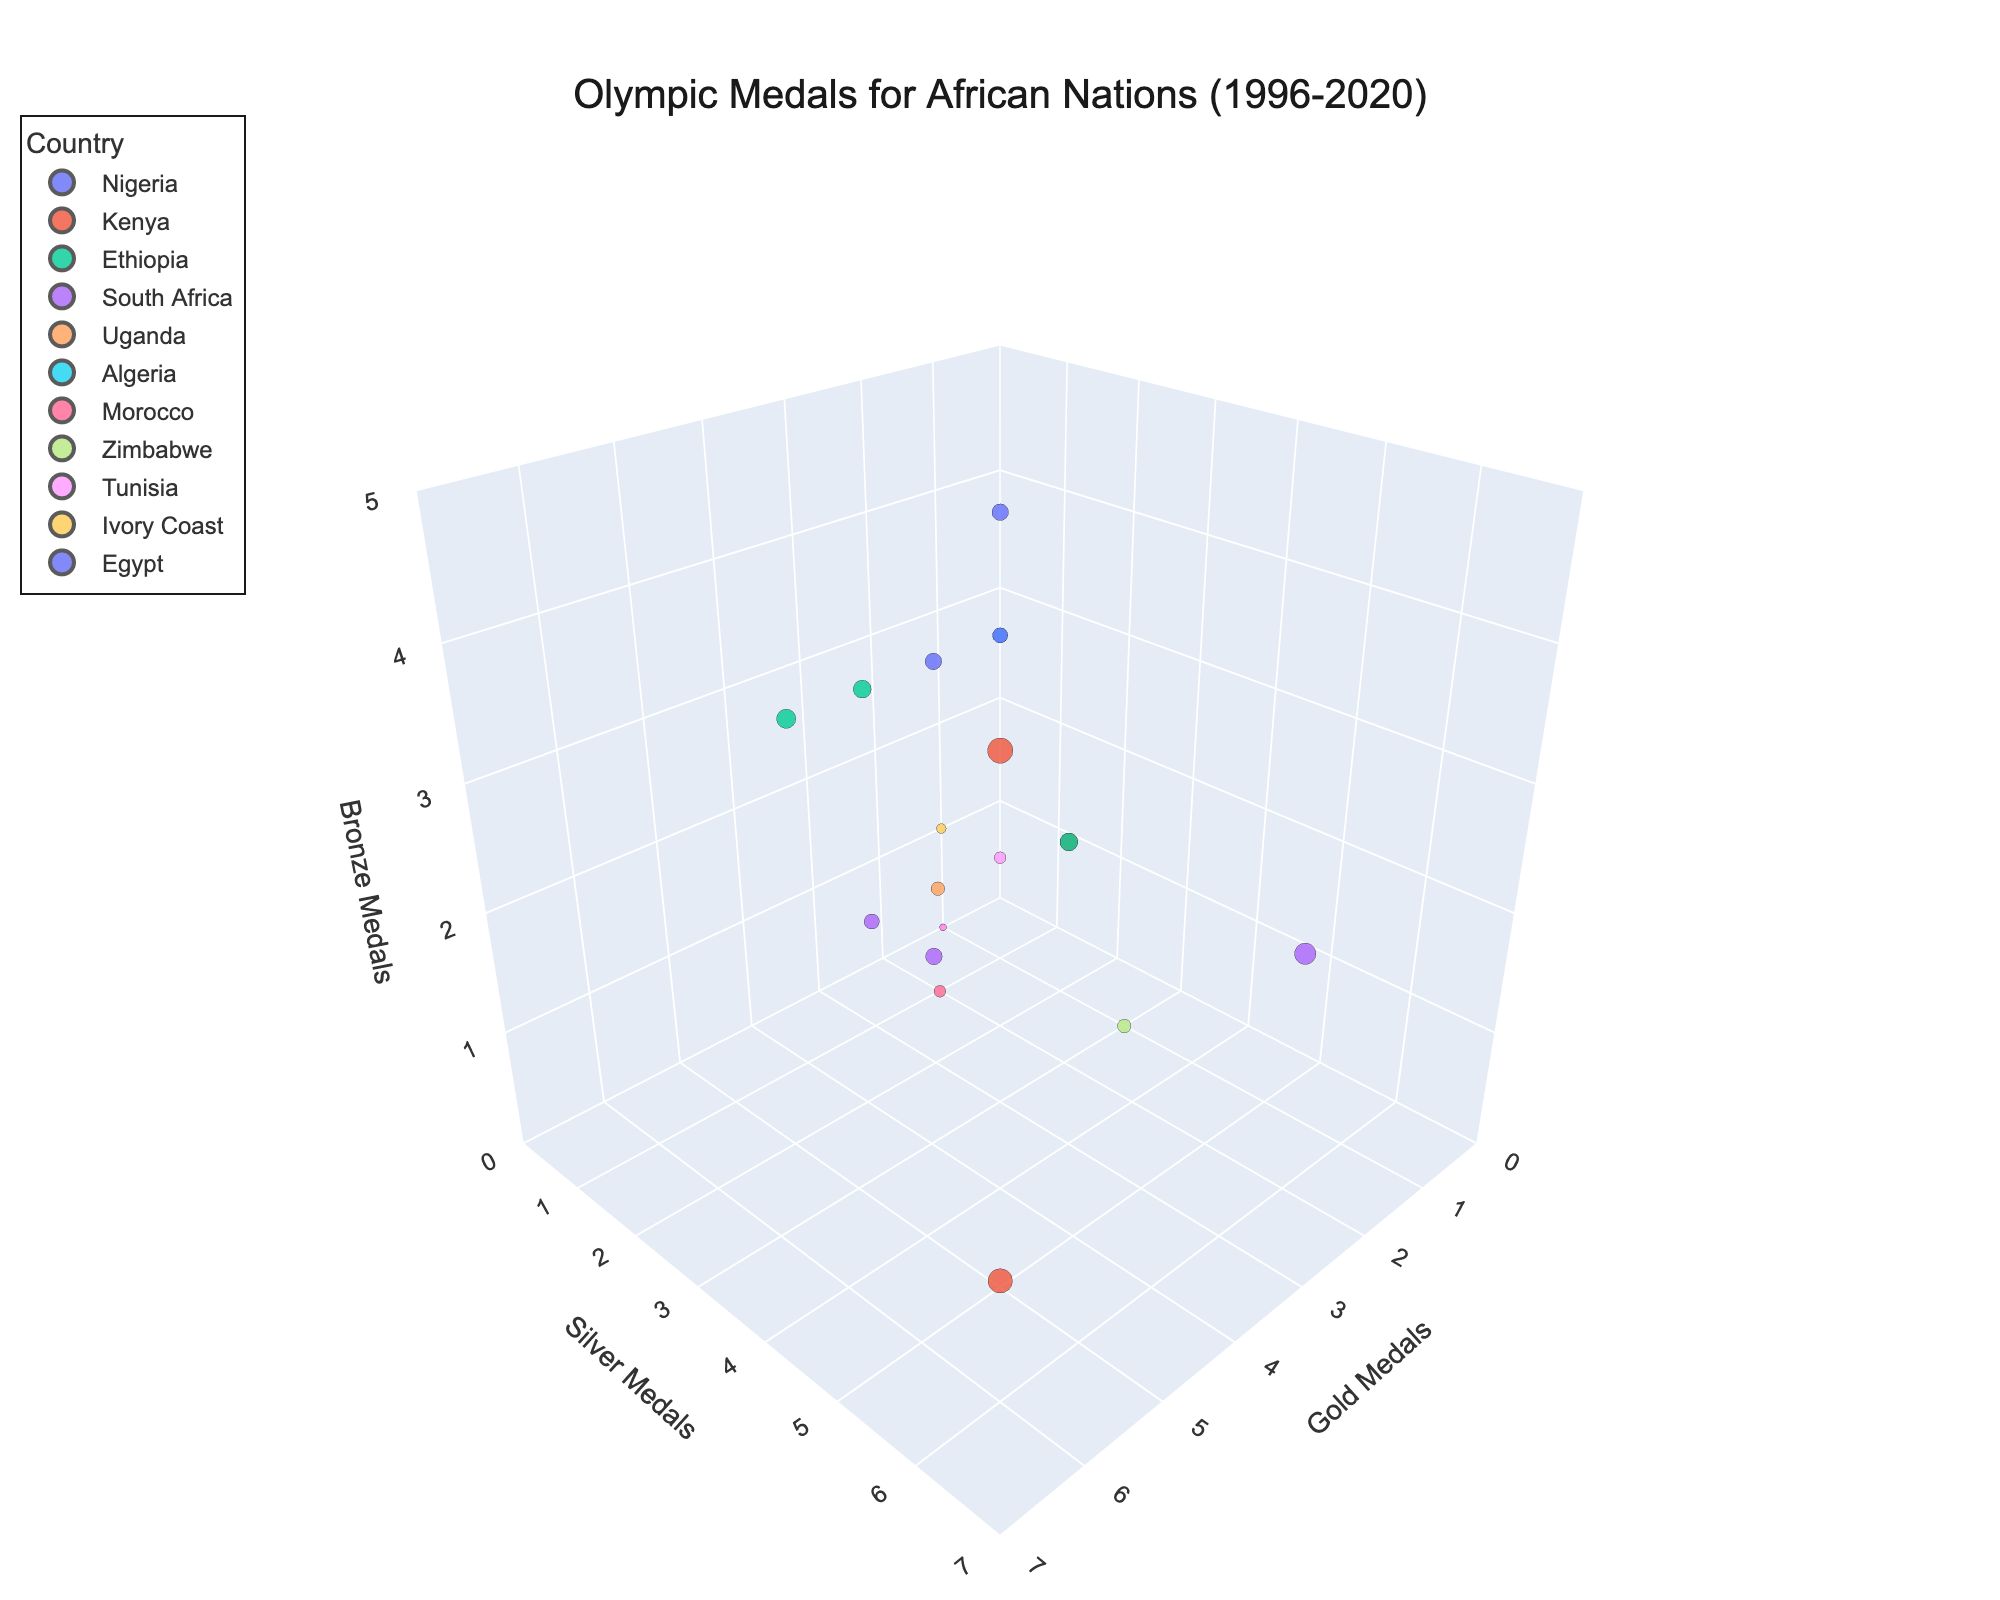Which country has the highest combined medal count? The sum of Gold, Silver, and Bronze medals needs to be calculated for each country. By inspecting the plot, Kenya dominates with higher values in multiple years. To conclude definitively, Kenya has the highest combined medal count in multiple years such as 2008 and 2016.
Answer: Kenya How many gold medals did South Africa win in total from 1996 to 2020? By visually adding the gold medals from South Africa across all the years: 3 (1996) + 3 (2012) + 2 (2016) = 8 gold medals.
Answer: 8 Which country had the best performance in the 2016 Olympics? We need to identify the data points from 2016 and compare the total medals. Kenya in 2016 has the highest number of gold (6), silver (6), and a bronze (1) making 13 medals in total.
Answer: Kenya How many countries won at least one silver medal? We count the distinct data points on the Y-axis (Silver Medals) where value > 0. Visually, there are multiple such countries: South Africa, Kenya, Ethiopia, Zimbabwe, Tunisia, and others.
Answer: 9 What's the difference in total medal count between Kenya and Ethiopia in the 2004 Olympics? For Kenya in 2004, the total medals are: 2 (Gold) + 3 (Silver) + 2 (Bronze) = 7. For Ethiopia in the same year, it's 2 (Gold) + 3 (Silver) + 2 (Bronze) = 7. The difference is 0.
Answer: 0 Which African nation had a notable increase in gold medals from 2008 to 2016? By comparing the data points, Kenya shows an increase from 5 gold medals in 2008 to 6 in 2016. Other countries remain stable or show an increase with lesser significance.
Answer: Kenya Did any country win exactly one medal of each color in any Olympiad? By inspecting the data points with equal spans on all three axes (1, 1, 1), Uganda in 2020 has (2, 1,1) but examining South Africa in 2012 shows (3, 2,1). Hence, no country won exactly one of each.
Answer: No What is the total number of Olympic medals won by Kenya? Summing up all the medals (Gold, Silver, Bronze) Kenya won across all the showcased years (2000, 2004, 2008, 2016): 2 + 3 + 2 + 5 + 5 + 4 + 6 + 6 + 1 = 34.
Answer: 34 In which year did South Africa win the highest number of medals? We compare the total medal counts for South Africa across the years 1996, 2012, 2016. South Africa won the most (10) in 2016 (2 Gold, 6 Silver, 2 Bronze).
Answer: 2016 What's the sum of bronze medals for Algeria and Egypt in the data provided? Adding Algeria's bronze from 2000 (3) and Egypt's from 2004 & 2020 (3 + 4) gives us the total: 3 + 3 + 4 = 10.
Answer: 10 